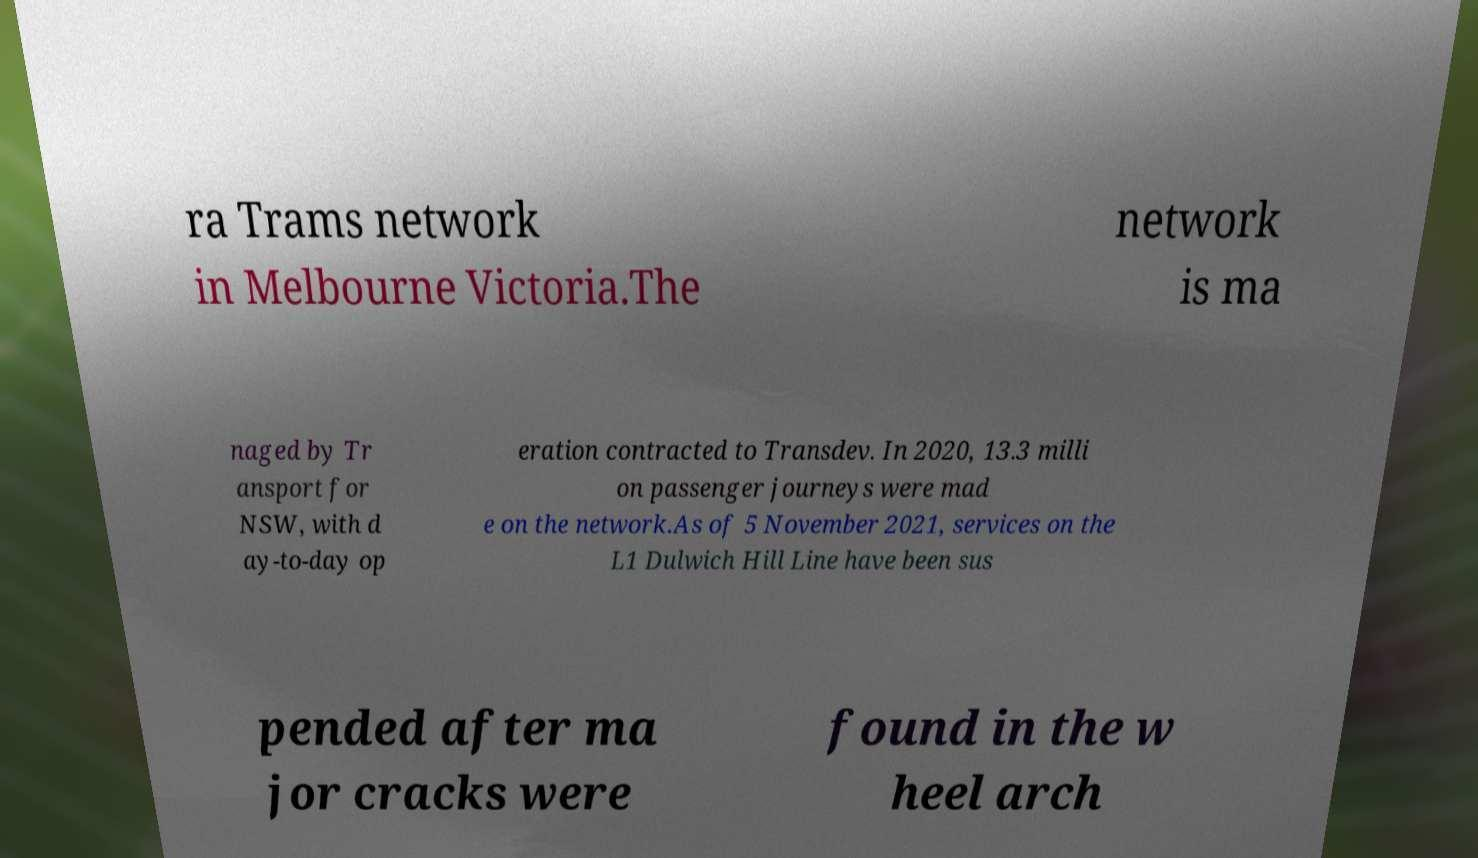Can you read and provide the text displayed in the image?This photo seems to have some interesting text. Can you extract and type it out for me? ra Trams network in Melbourne Victoria.The network is ma naged by Tr ansport for NSW, with d ay-to-day op eration contracted to Transdev. In 2020, 13.3 milli on passenger journeys were mad e on the network.As of 5 November 2021, services on the L1 Dulwich Hill Line have been sus pended after ma jor cracks were found in the w heel arch 